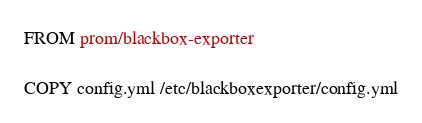Convert code to text. <code><loc_0><loc_0><loc_500><loc_500><_Dockerfile_>FROM prom/blackbox-exporter

COPY config.yml /etc/blackboxexporter/config.yml</code> 